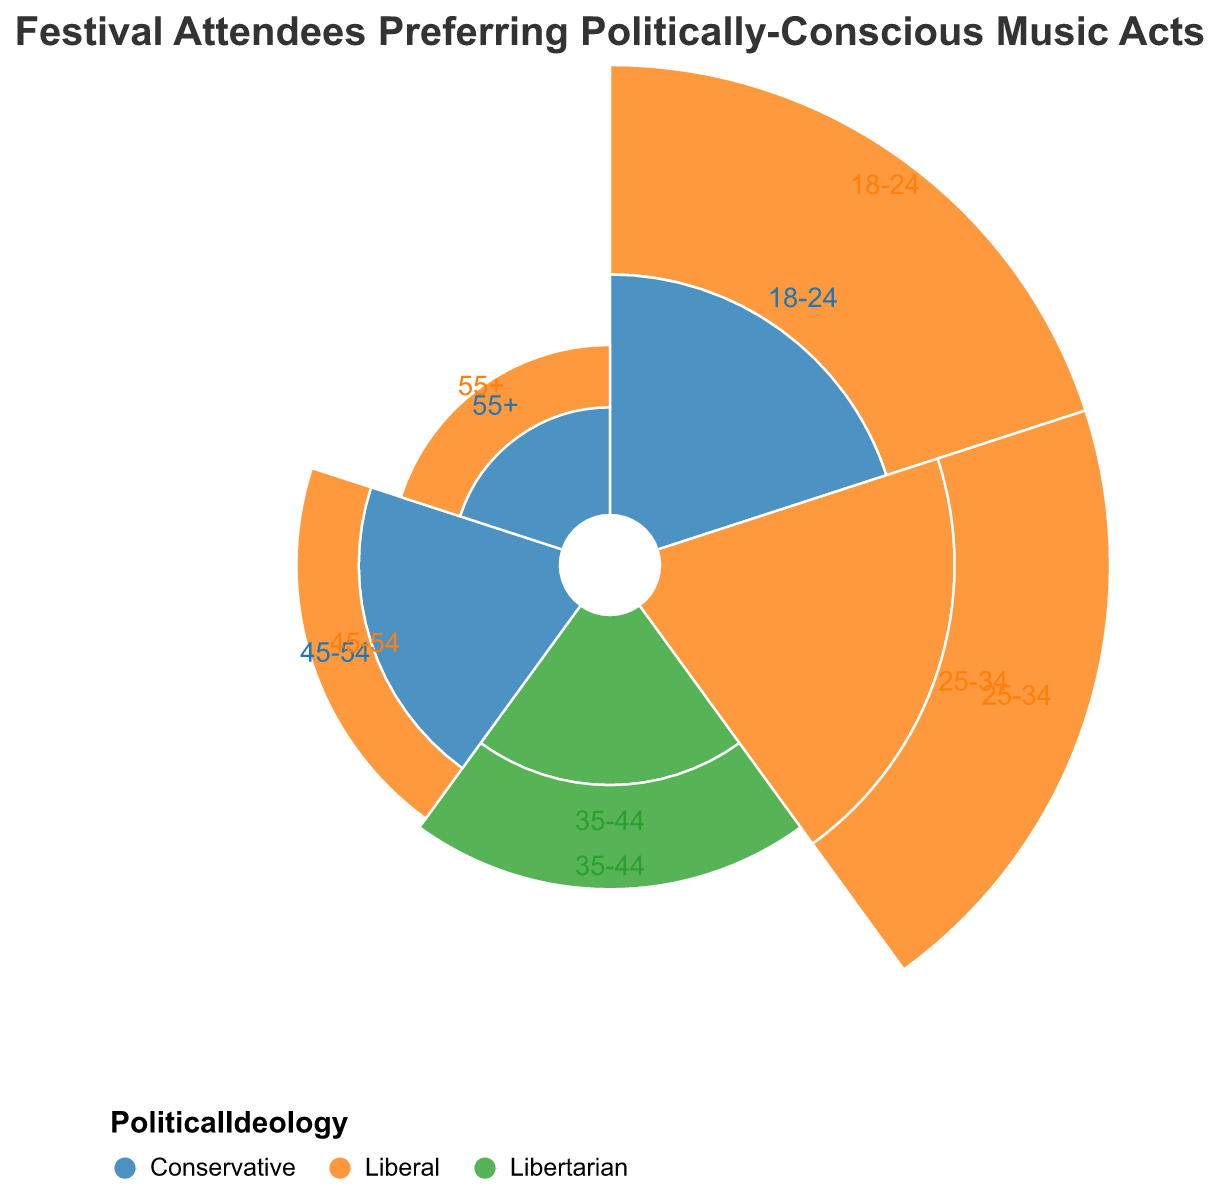What percentage of attendees aged 18-24 and supporting Liberal ideology are there? According to the figure, the percentage of attendees in the 18-24 age group who identify as Liberal is represented by the Male and falls under 'Urban' with a value of 25%.
Answer: 25% Amongst the attendees aged 25-34, which gender and political ideology has a higher percentage? For age group 25-34, the Liberal ideology appears twice: 15% for Female (Rural) and 20% for Male (Urban). The percentage is higher for Male.
Answer: Male Liberal Which age group has the lowest percentage of attendees, and what is their political ideology and demographics? By examining the figure, the age group with the lowest percentage of attendees is 55+ with Male being Conservative and located in 'Rural' areas. Their percentage is 2%.
Answer: 55+ Male Conservative Rural What is the total percentage of attendees who identify with Conservative ideology across all age groups? Add the percentages of attendees who identify as Conservative: 18-24 Female Suburban (10%), 45-54 Female Rural (7%), and 55+ Male Rural (2%). Summing these gives 10 + 7 + 2 = 19%.
Answer: 19% Compare the percentage of Urban attendees who prefer Liberal ideology in the 18-24 group versus the 25-34 group. Which group is greater and by how much? The Urban Liberal attendees are 25% for the 18-24 Male group and 20% for the 25-34 Male group. The 18-24 group is greater by 25% - 20% = 5%.
Answer: The 18-24 group, by 5% Which political ideology appears most frequently across all age groups and demographics? Count the occurrences of each political ideology: Liberal appears 6 times, Conservative 3 times, and Libertarian 2 times. Liberal appears most frequently.
Answer: Liberal What is the combined percentage of festival attendees aged 35-44 identifying as Libertarian? Combine both entries for attendees aged 35-44 who identify as Libertarian: Male Suburban (5%) and Female Urban (8%). 5 + 8 = 13%.
Answer: 13% How does the percentage of Rural attendees in the 45-54 age group compare with the 25-34 age group? For 45-54 age group: Female Conservative in Rural (7%). For 25-34 age group: Female Liberal in Rural (15%). The 25-34 group has a higher percentage by 15% - 7% = 8%.
Answer: The 25-34 group, by 8% What percentage of attendees are both Female and identify as Liberal? Summing the percentages for Female Liberal attendees: 25-34 Rural (15%), 55+ Urban (3%). Adding these together results in 15 + 3 = 18%.
Answer: 18% 